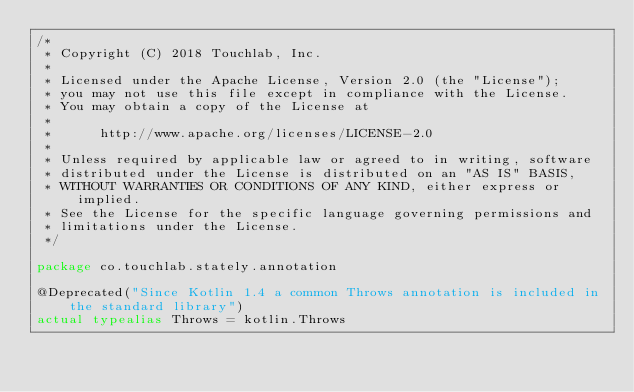<code> <loc_0><loc_0><loc_500><loc_500><_Kotlin_>/*
 * Copyright (C) 2018 Touchlab, Inc.
 *
 * Licensed under the Apache License, Version 2.0 (the "License");
 * you may not use this file except in compliance with the License.
 * You may obtain a copy of the License at
 *
 *      http://www.apache.org/licenses/LICENSE-2.0
 *
 * Unless required by applicable law or agreed to in writing, software
 * distributed under the License is distributed on an "AS IS" BASIS,
 * WITHOUT WARRANTIES OR CONDITIONS OF ANY KIND, either express or implied.
 * See the License for the specific language governing permissions and
 * limitations under the License.
 */

package co.touchlab.stately.annotation

@Deprecated("Since Kotlin 1.4 a common Throws annotation is included in the standard library")
actual typealias Throws = kotlin.Throws</code> 